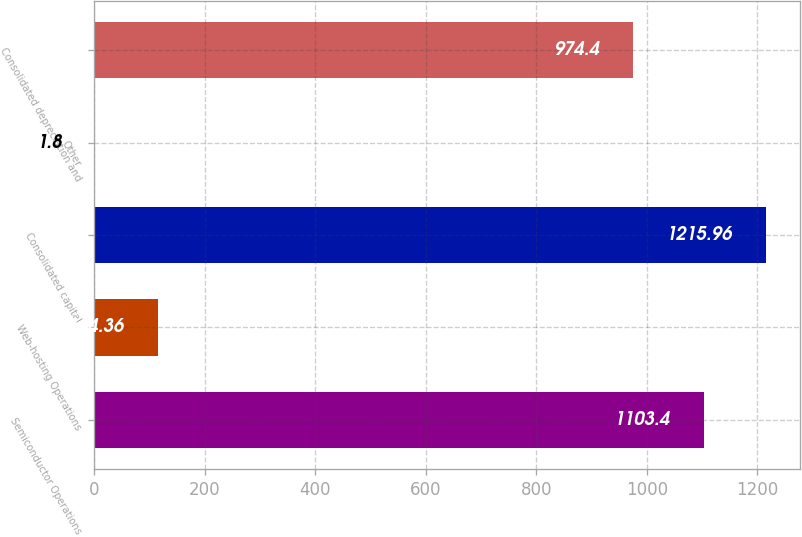Convert chart to OTSL. <chart><loc_0><loc_0><loc_500><loc_500><bar_chart><fcel>Semiconductor Operations<fcel>Web-hosting Operations<fcel>Consolidated capital<fcel>Other<fcel>Consolidated depreciation and<nl><fcel>1103.4<fcel>114.36<fcel>1215.96<fcel>1.8<fcel>974.4<nl></chart> 